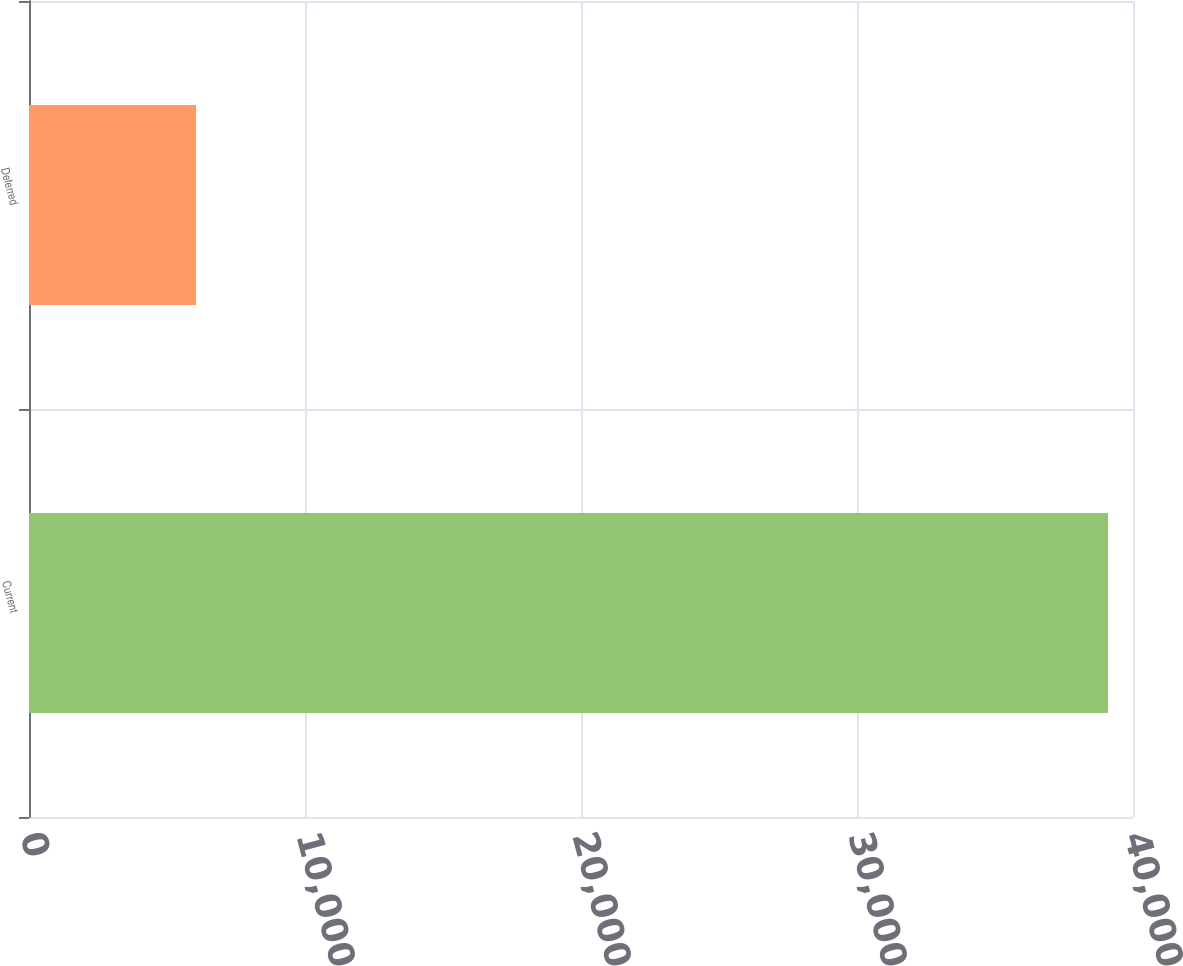Convert chart. <chart><loc_0><loc_0><loc_500><loc_500><bar_chart><fcel>Current<fcel>Deferred<nl><fcel>39096<fcel>6053<nl></chart> 